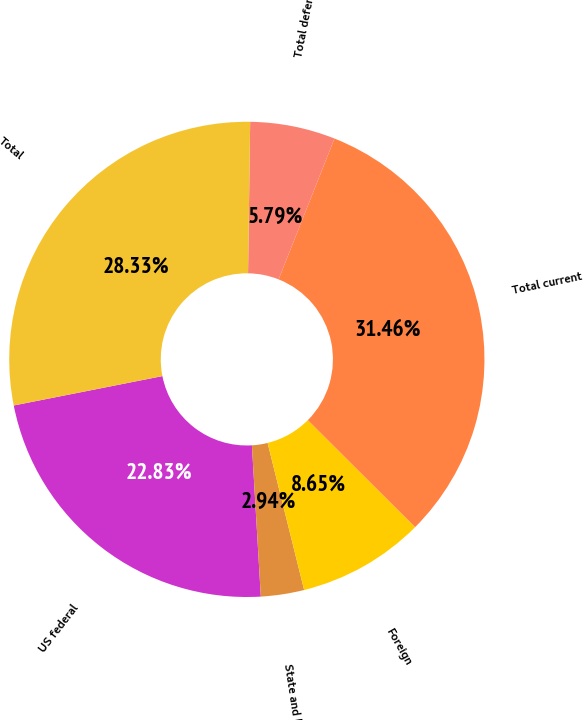Convert chart. <chart><loc_0><loc_0><loc_500><loc_500><pie_chart><fcel>US federal<fcel>State and local<fcel>Foreign<fcel>Total current<fcel>Total deferred<fcel>Total<nl><fcel>22.83%<fcel>2.94%<fcel>8.65%<fcel>31.46%<fcel>5.79%<fcel>28.33%<nl></chart> 